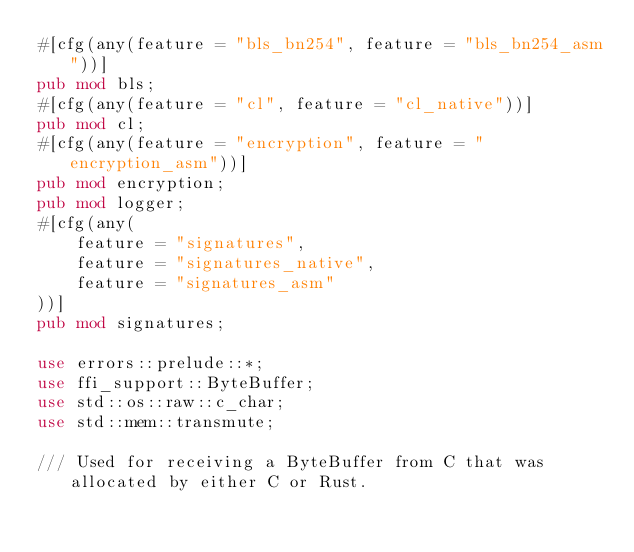Convert code to text. <code><loc_0><loc_0><loc_500><loc_500><_Rust_>#[cfg(any(feature = "bls_bn254", feature = "bls_bn254_asm"))]
pub mod bls;
#[cfg(any(feature = "cl", feature = "cl_native"))]
pub mod cl;
#[cfg(any(feature = "encryption", feature = "encryption_asm"))]
pub mod encryption;
pub mod logger;
#[cfg(any(
    feature = "signatures",
    feature = "signatures_native",
    feature = "signatures_asm"
))]
pub mod signatures;

use errors::prelude::*;
use ffi_support::ByteBuffer;
use std::os::raw::c_char;
use std::mem::transmute;

/// Used for receiving a ByteBuffer from C that was allocated by either C or Rust.</code> 